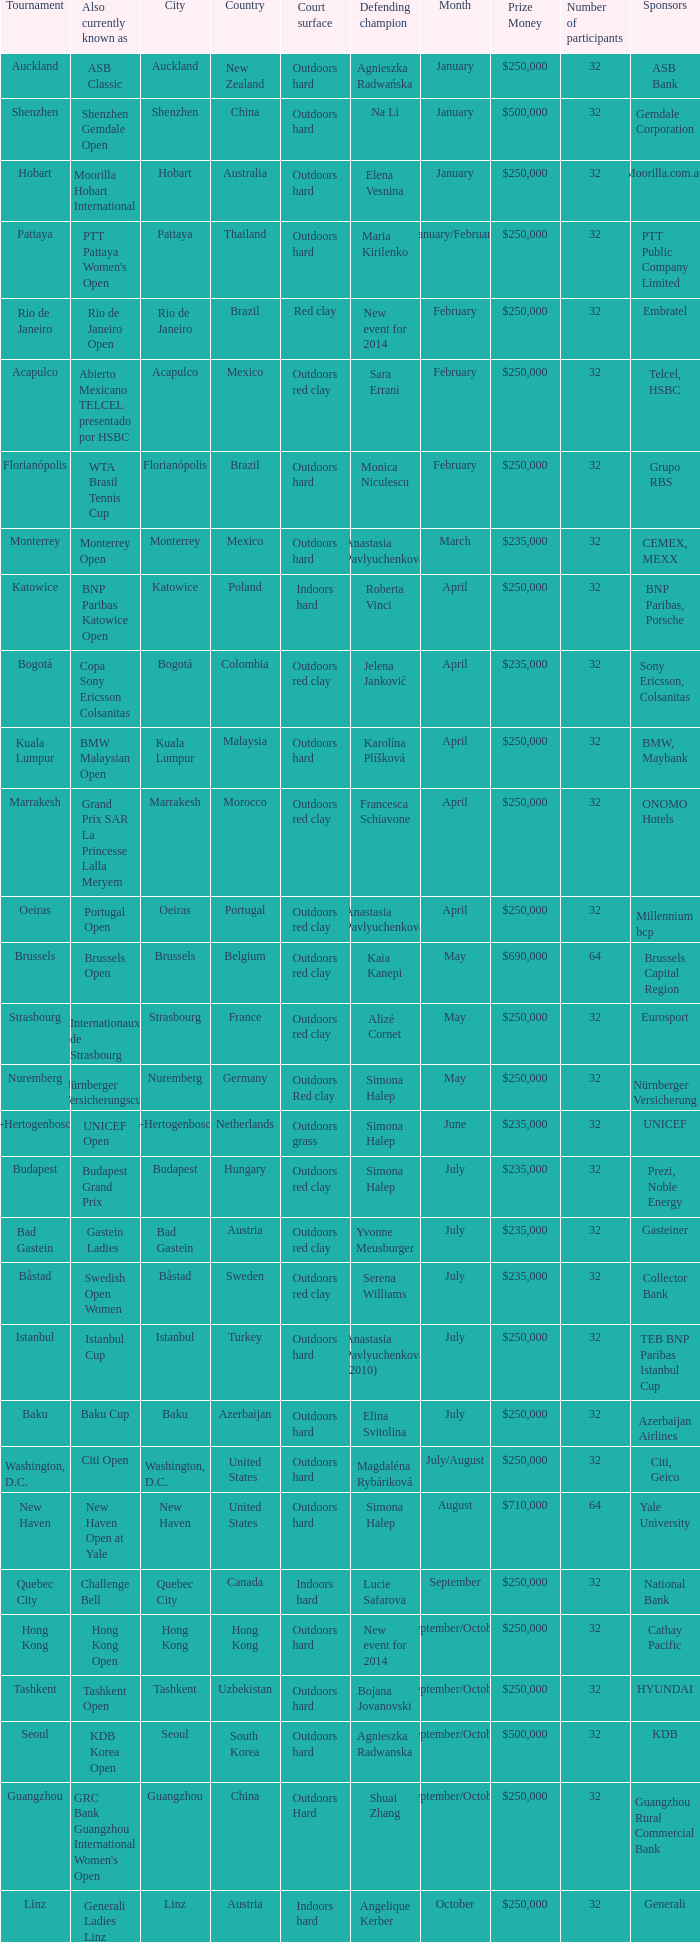What tournament is in katowice? Katowice. 